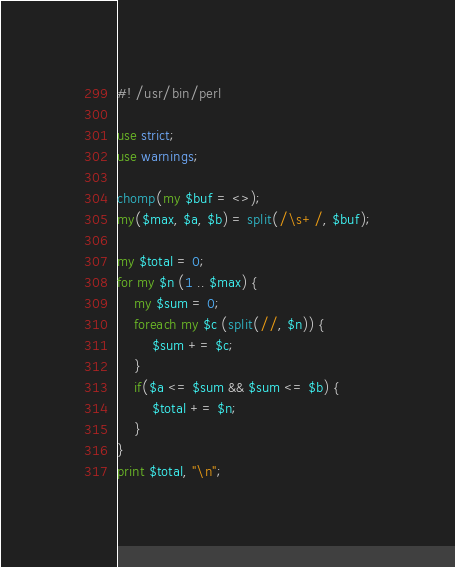<code> <loc_0><loc_0><loc_500><loc_500><_Perl_>#! /usr/bin/perl

use strict;
use warnings;

chomp(my $buf = <>);
my($max, $a, $b) = split(/\s+/, $buf);

my $total = 0;
for my $n (1 .. $max) {
    my $sum = 0;
    foreach my $c (split(//, $n)) {
        $sum += $c;
    }
    if($a <= $sum && $sum <= $b) {
        $total += $n;
    }
}
print $total, "\n";
</code> 